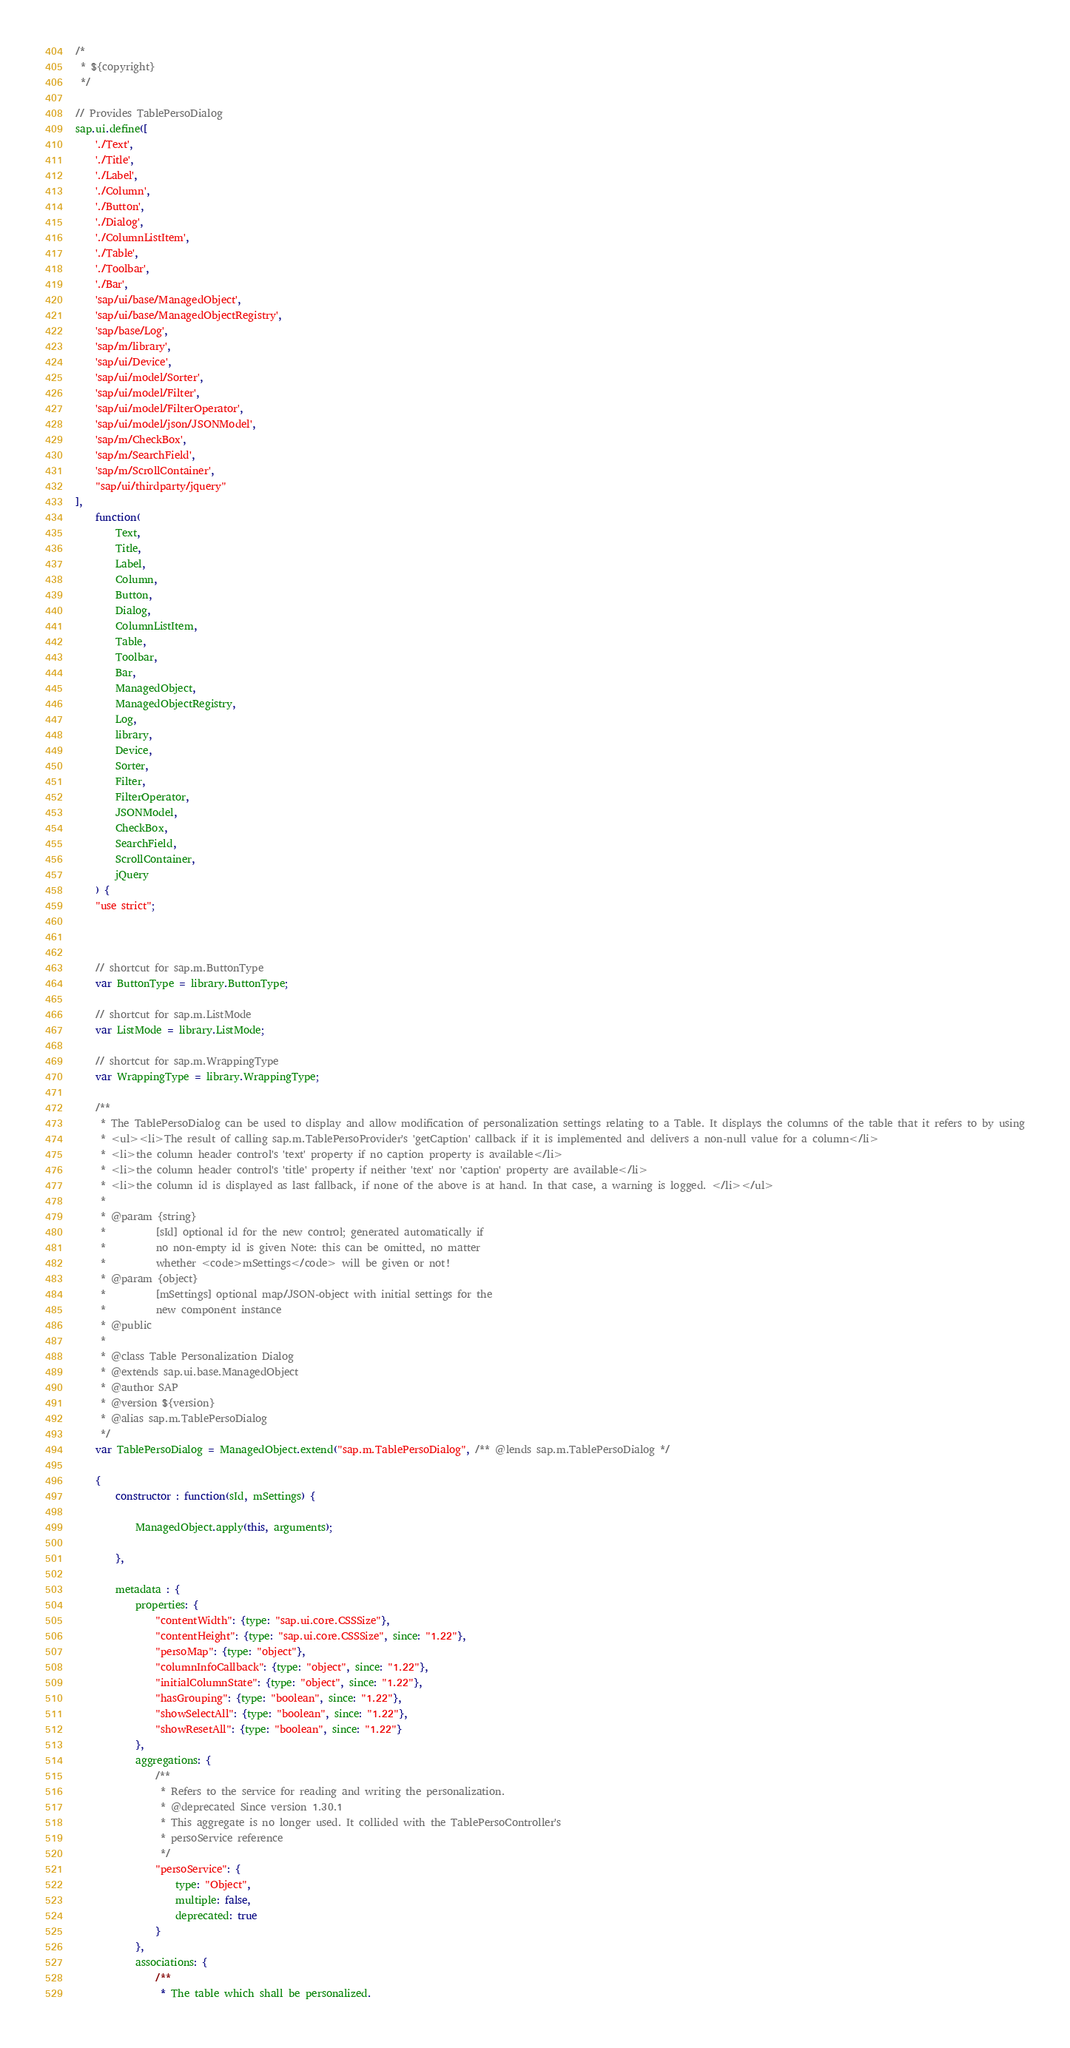<code> <loc_0><loc_0><loc_500><loc_500><_JavaScript_>/*
 * ${copyright}
 */

// Provides TablePersoDialog
sap.ui.define([
	'./Text',
	'./Title',
	'./Label',
	'./Column',
	'./Button',
	'./Dialog',
	'./ColumnListItem',
	'./Table',
	'./Toolbar',
	'./Bar',
	'sap/ui/base/ManagedObject',
	'sap/ui/base/ManagedObjectRegistry',
	'sap/base/Log',
	'sap/m/library',
	'sap/ui/Device',
	'sap/ui/model/Sorter',
	'sap/ui/model/Filter',
	'sap/ui/model/FilterOperator',
	'sap/ui/model/json/JSONModel',
	'sap/m/CheckBox',
	'sap/m/SearchField',
	'sap/m/ScrollContainer',
	"sap/ui/thirdparty/jquery"
],
	function(
		Text,
		Title,
		Label,
		Column,
		Button,
		Dialog,
		ColumnListItem,
		Table,
		Toolbar,
		Bar,
		ManagedObject,
		ManagedObjectRegistry,
		Log,
		library,
		Device,
		Sorter,
		Filter,
		FilterOperator,
		JSONModel,
		CheckBox,
		SearchField,
		ScrollContainer,
		jQuery
	) {
	"use strict";



	// shortcut for sap.m.ButtonType
	var ButtonType = library.ButtonType;

	// shortcut for sap.m.ListMode
	var ListMode = library.ListMode;

	// shortcut for sap.m.WrappingType
	var WrappingType = library.WrappingType;

	/**
	 * The TablePersoDialog can be used to display and allow modification of personalization settings relating to a Table. It displays the columns of the table that it refers to by using
	 * <ul><li>The result of calling sap.m.TablePersoProvider's 'getCaption' callback if it is implemented and delivers a non-null value for a column</li>
	 * <li>the column header control's 'text' property if no caption property is available</li>
	 * <li>the column header control's 'title' property if neither 'text' nor 'caption' property are available</li>
	 * <li>the column id is displayed as last fallback, if none of the above is at hand. In that case, a warning is logged. </li></ul>
	 *
	 * @param {string}
	 *			[sId] optional id for the new control; generated automatically if
	 *			no non-empty id is given Note: this can be omitted, no matter
	 *			whether <code>mSettings</code> will be given or not!
	 * @param {object}
	 *			[mSettings] optional map/JSON-object with initial settings for the
	 *			new component instance
	 * @public
	 *
	 * @class Table Personalization Dialog
	 * @extends sap.ui.base.ManagedObject
	 * @author SAP
	 * @version ${version}
	 * @alias sap.m.TablePersoDialog
	 */
	var TablePersoDialog = ManagedObject.extend("sap.m.TablePersoDialog", /** @lends sap.m.TablePersoDialog */

	{
		constructor : function(sId, mSettings) {

			ManagedObject.apply(this, arguments);

		},

		metadata : {
			properties: {
				"contentWidth": {type: "sap.ui.core.CSSSize"},
				"contentHeight": {type: "sap.ui.core.CSSSize", since: "1.22"},
				"persoMap": {type: "object"},
				"columnInfoCallback": {type: "object", since: "1.22"},
				"initialColumnState": {type: "object", since: "1.22"},
				"hasGrouping": {type: "boolean", since: "1.22"},
				"showSelectAll": {type: "boolean", since: "1.22"},
				"showResetAll": {type: "boolean", since: "1.22"}
			},
			aggregations: {
				/**
				 * Refers to the service for reading and writing the personalization.
				 * @deprecated Since version 1.30.1
				 * This aggregate is no longer used. It collided with the TablePersoController's
				 * persoService reference
				 */
				"persoService": {
					type: "Object",
					multiple: false,
					deprecated: true
				}
			},
			associations: {
				/**
				 * The table which shall be personalized.</code> 